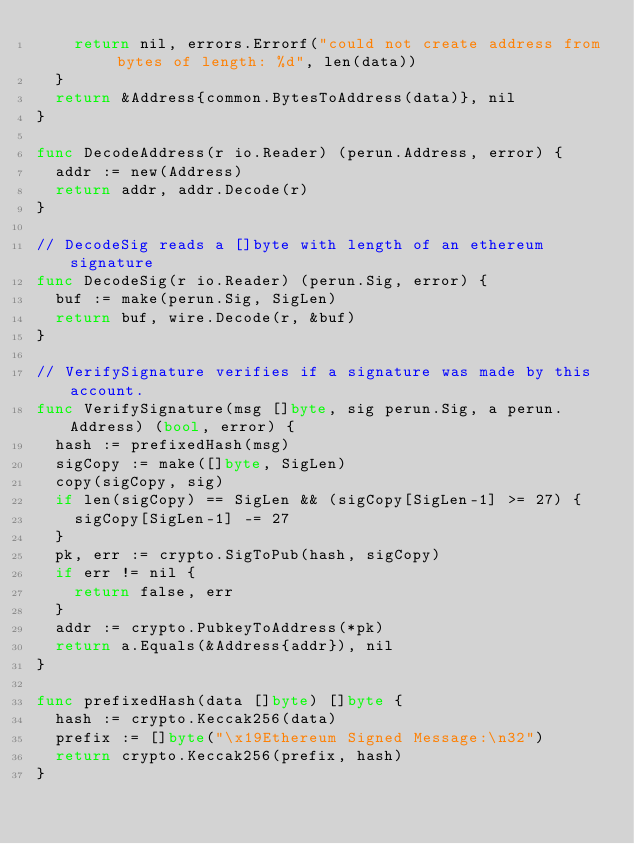<code> <loc_0><loc_0><loc_500><loc_500><_Go_>		return nil, errors.Errorf("could not create address from bytes of length: %d", len(data))
	}
	return &Address{common.BytesToAddress(data)}, nil
}

func DecodeAddress(r io.Reader) (perun.Address, error) {
	addr := new(Address)
	return addr, addr.Decode(r)
}

// DecodeSig reads a []byte with length of an ethereum signature
func DecodeSig(r io.Reader) (perun.Sig, error) {
	buf := make(perun.Sig, SigLen)
	return buf, wire.Decode(r, &buf)
}

// VerifySignature verifies if a signature was made by this account.
func VerifySignature(msg []byte, sig perun.Sig, a perun.Address) (bool, error) {
	hash := prefixedHash(msg)
	sigCopy := make([]byte, SigLen)
	copy(sigCopy, sig)
	if len(sigCopy) == SigLen && (sigCopy[SigLen-1] >= 27) {
		sigCopy[SigLen-1] -= 27
	}
	pk, err := crypto.SigToPub(hash, sigCopy)
	if err != nil {
		return false, err
	}
	addr := crypto.PubkeyToAddress(*pk)
	return a.Equals(&Address{addr}), nil
}

func prefixedHash(data []byte) []byte {
	hash := crypto.Keccak256(data)
	prefix := []byte("\x19Ethereum Signed Message:\n32")
	return crypto.Keccak256(prefix, hash)
}
</code> 